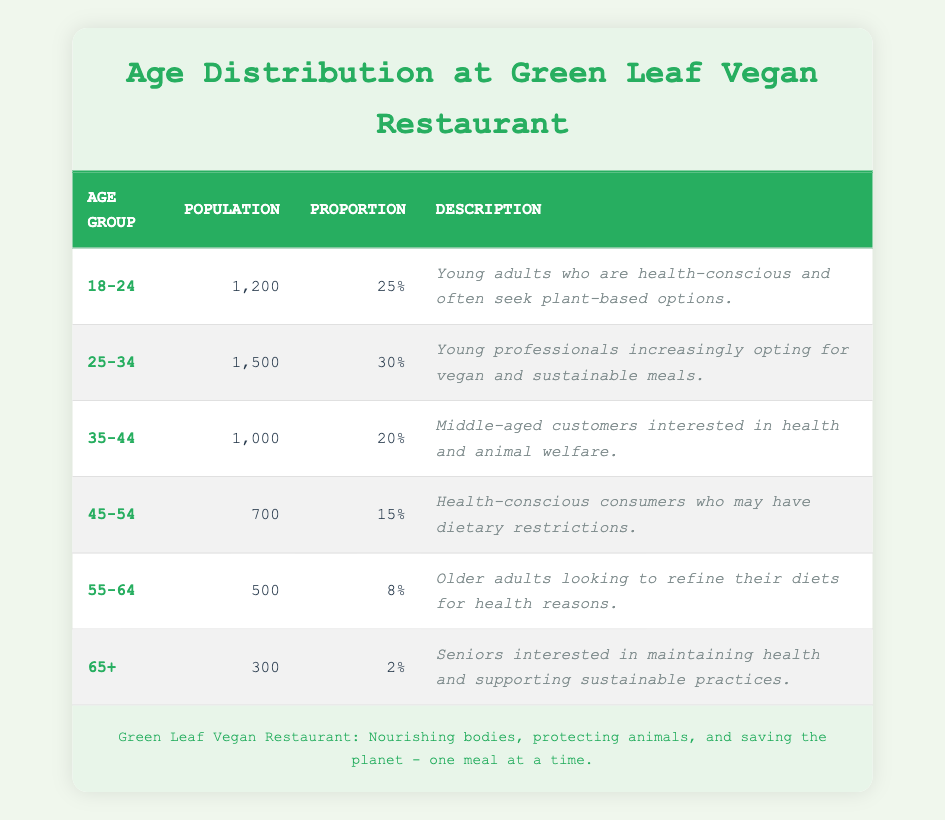What is the population of the age group 25-34? The table lists the population for each age group. For the age group 25-34, the population is given directly as 1500.
Answer: 1500 What proportion of customers are aged 65 and older? The proportion of customers aged 65 and older is listed in the table under the "Proportion" column for that age group, which is 2%.
Answer: 2% Which age group has the highest population? By comparing the population values, the age group 25-34 has the highest population at 1500, as it is the largest number listed in the "Population" column.
Answer: 25-34 What is the total population of customers aged 45-64? To find this, we sum the populations of the age groups 45-54 and 55-64. This gives us 700 (for 45-54) + 500 (for 55-64) = 1200.
Answer: 1200 Is it true that there are more customers aged 35-44 than 55-64? The population for the age group 35-44 is 1000, while for 55-64 it is 500. Since 1000 is greater than 500, the statement is true.
Answer: Yes What is the average proportion of the age groups 18-24 and 45-54? The proportions for these age groups are 25% and 15%. To find the average, we add them: 25 + 15 = 40, and then divide by 2, giving us 40/2 = 20%.
Answer: 20% Which age group represents the smallest proportion of the customer base? Reviewing the "Proportion" column, the group 65+ has the smallest proportion at 2%, indicating it makes up the least part of the customer demographics.
Answer: 65+ What is the difference in population between the age groups 18-24 and 45-54? The population for 18-24 is 1200 and for 45-54, it is 700. The difference is 1200 - 700 = 500.
Answer: 500 What percentage of the total population do the age groups 55-64 and 65+ combined represent? First, we sum the populations of age groups 55-64 (500) and 65+ (300) to get 800. The total population across all age groups is 4000 (sum of all populations). The percentage is (800/4000) * 100 = 20%.
Answer: 20% 